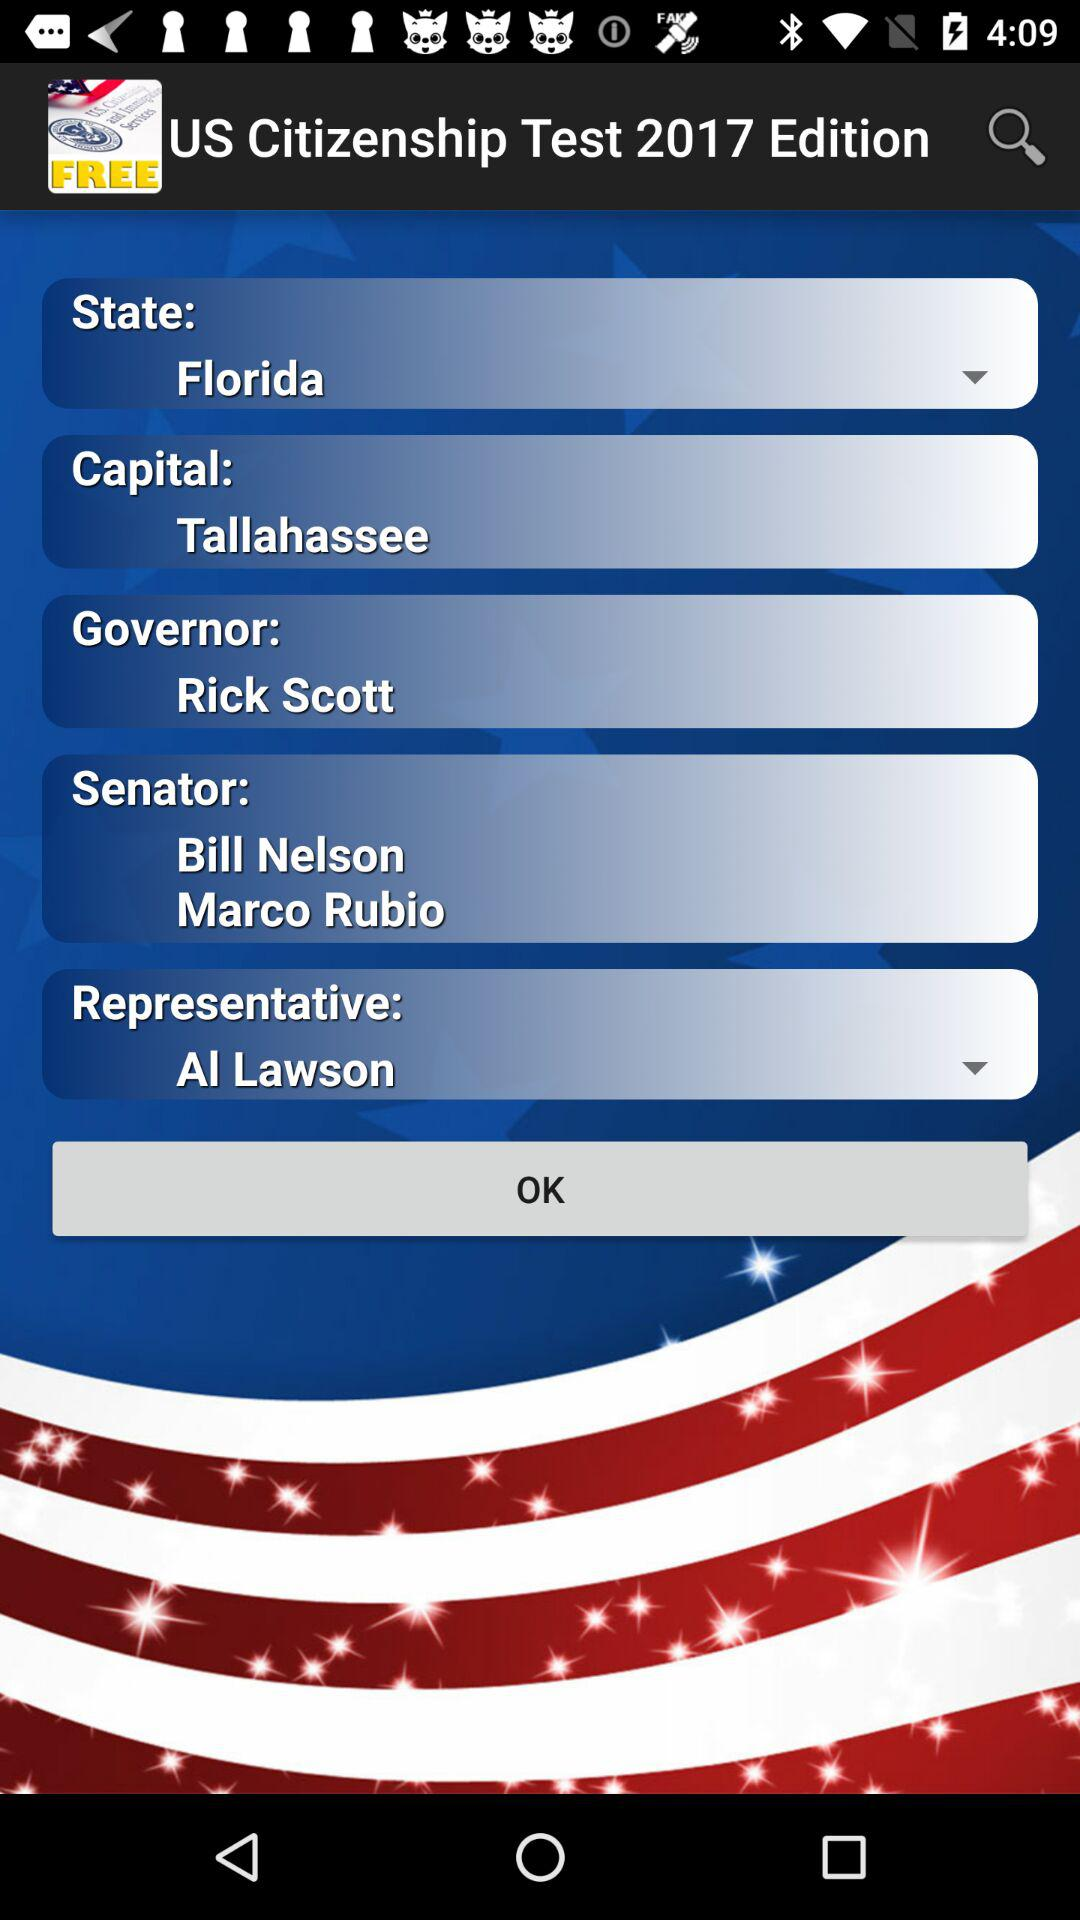How many more senators are there than representatives?
Answer the question using a single word or phrase. 1 